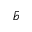<formula> <loc_0><loc_0><loc_500><loc_500>\bar { b }</formula> 